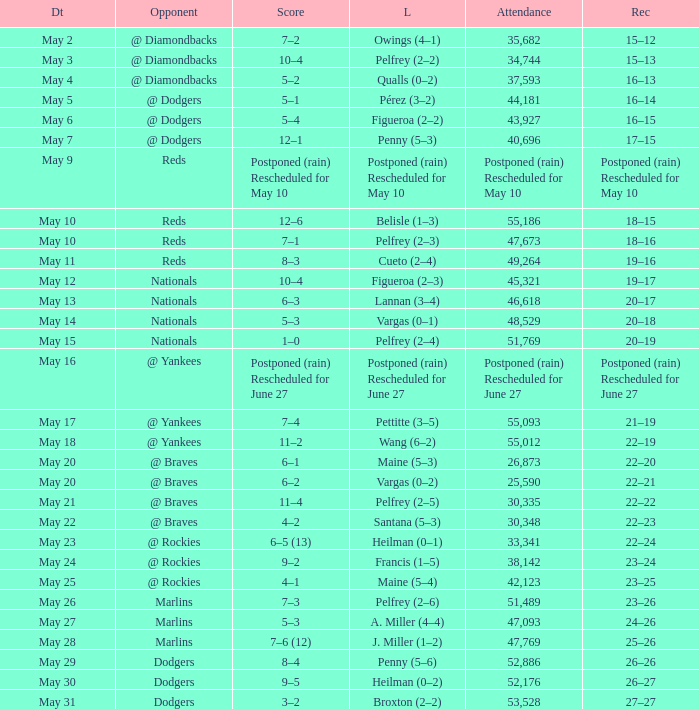Score of postponed (rain) rescheduled for June 27 had what loss? Postponed (rain) Rescheduled for June 27. 